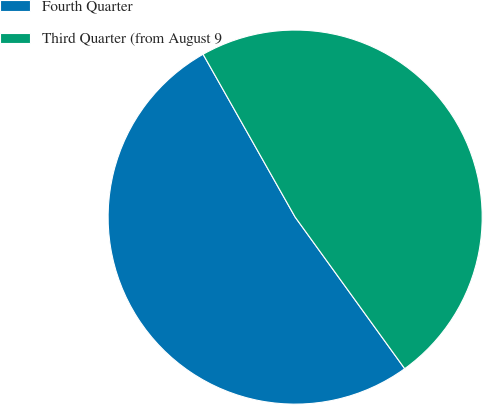<chart> <loc_0><loc_0><loc_500><loc_500><pie_chart><fcel>Fourth Quarter<fcel>Third Quarter (from August 9<nl><fcel>51.77%<fcel>48.23%<nl></chart> 